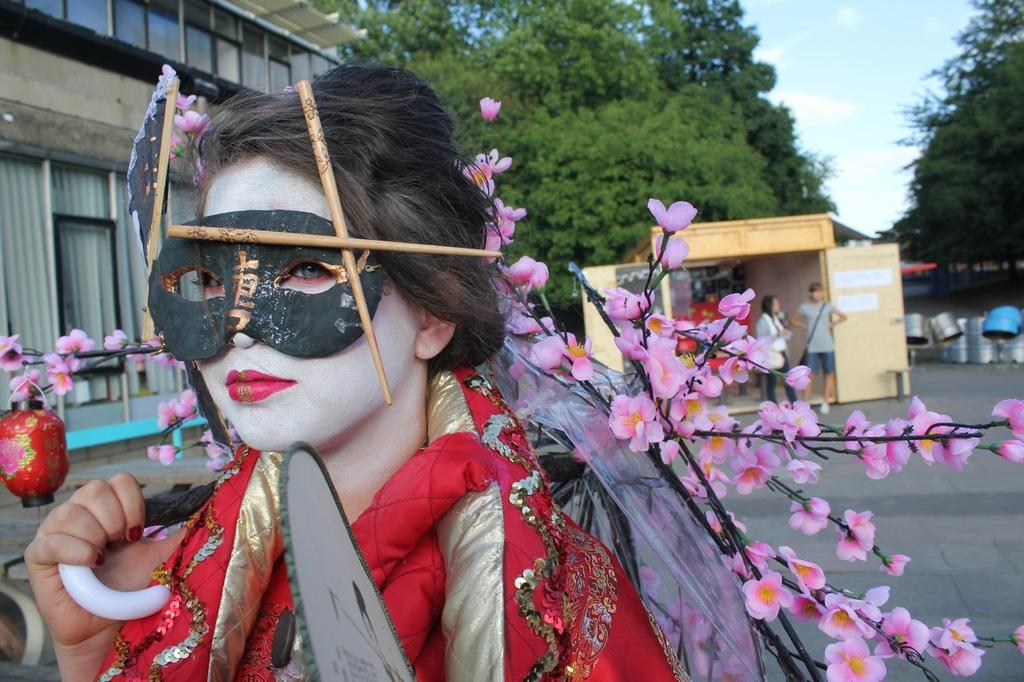What is the main subject of the image? There is a person in the image. How is the person dressed? The person is wearing a different costume. What is covering the person's face? The person has a mask on their face. What can be seen in the background of the image? There are trees, houses, and people visible in the background of the image, as well as other unspecified things. What type of metal is being used to secure the lock on the door in the image? There is no door or lock present in the image; it features a person wearing a costume and mask. What is the person in the image needing to do? The image does not provide information about what the person needs to do. 